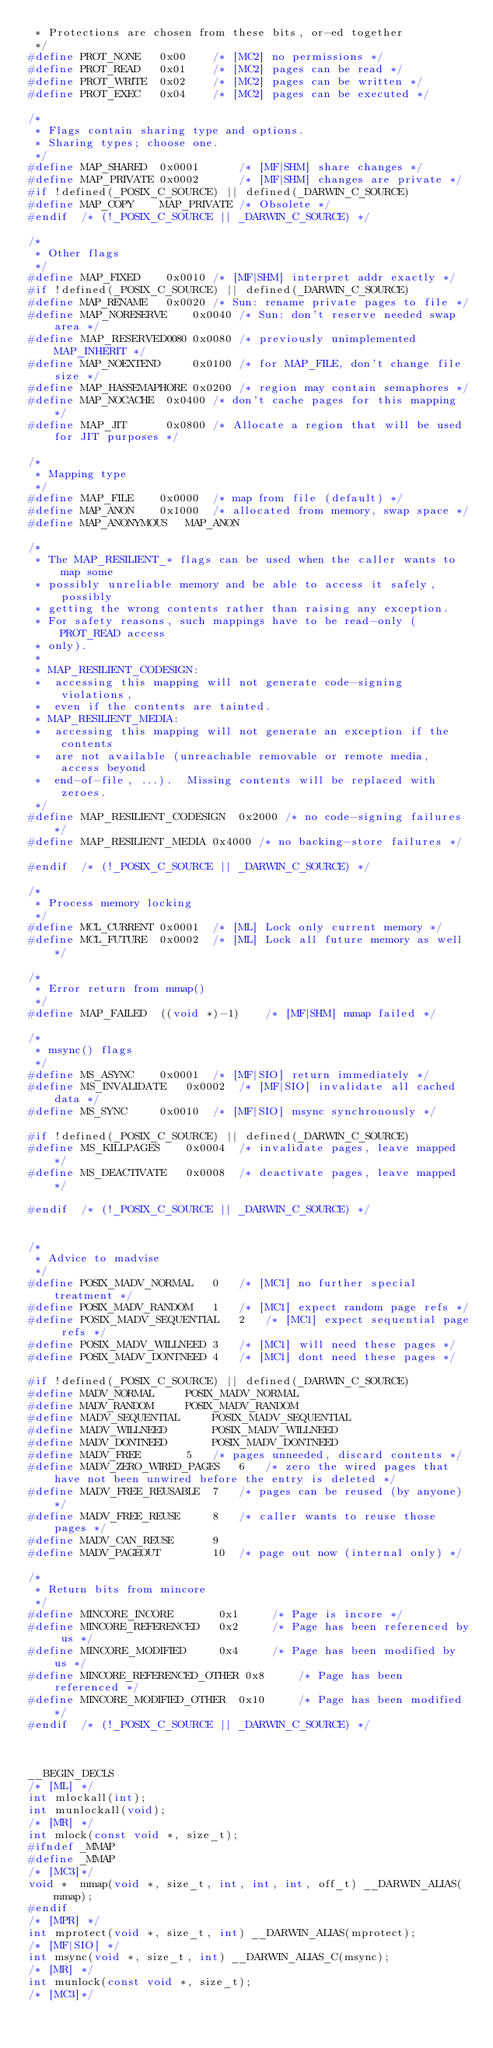Convert code to text. <code><loc_0><loc_0><loc_500><loc_500><_C_> * Protections are chosen from these bits, or-ed together
 */
#define	PROT_NONE	0x00	/* [MC2] no permissions */
#define	PROT_READ	0x01	/* [MC2] pages can be read */
#define	PROT_WRITE	0x02	/* [MC2] pages can be written */
#define	PROT_EXEC	0x04	/* [MC2] pages can be executed */

/*
 * Flags contain sharing type and options.
 * Sharing types; choose one.
 */
#define	MAP_SHARED	0x0001		/* [MF|SHM] share changes */
#define	MAP_PRIVATE	0x0002		/* [MF|SHM] changes are private */
#if !defined(_POSIX_C_SOURCE) || defined(_DARWIN_C_SOURCE)
#define	MAP_COPY	MAP_PRIVATE	/* Obsolete */
#endif	/* (!_POSIX_C_SOURCE || _DARWIN_C_SOURCE) */

/*
 * Other flags
 */
#define	MAP_FIXED	 0x0010	/* [MF|SHM] interpret addr exactly */
#if !defined(_POSIX_C_SOURCE) || defined(_DARWIN_C_SOURCE)
#define	MAP_RENAME	 0x0020	/* Sun: rename private pages to file */
#define	MAP_NORESERVE	 0x0040	/* Sun: don't reserve needed swap area */
#define	MAP_RESERVED0080 0x0080	/* previously unimplemented MAP_INHERIT */
#define	MAP_NOEXTEND	 0x0100	/* for MAP_FILE, don't change file size */
#define	MAP_HASSEMAPHORE 0x0200	/* region may contain semaphores */
#define MAP_NOCACHE	 0x0400 /* don't cache pages for this mapping */
#define MAP_JIT		 0x0800 /* Allocate a region that will be used for JIT purposes */

/*
 * Mapping type
 */
#define	MAP_FILE	0x0000	/* map from file (default) */
#define	MAP_ANON	0x1000	/* allocated from memory, swap space */
#define	MAP_ANONYMOUS	MAP_ANON

/*
 * The MAP_RESILIENT_* flags can be used when the caller wants to map some
 * possibly unreliable memory and be able to access it safely, possibly
 * getting the wrong contents rather than raising any exception.
 * For safety reasons, such mappings have to be read-only (PROT_READ access
 * only).
 *
 * MAP_RESILIENT_CODESIGN:
 * 	accessing this mapping will not generate code-signing violations,
 *	even if the contents are tainted.
 * MAP_RESILIENT_MEDIA:
 *	accessing this mapping will not generate an exception if the contents
 *	are not available (unreachable removable or remote media, access beyond
 *	end-of-file, ...).  Missing contents will be replaced with zeroes.
 */
#define MAP_RESILIENT_CODESIGN	0x2000 /* no code-signing failures */
#define MAP_RESILIENT_MEDIA	0x4000 /* no backing-store failures */

#endif	/* (!_POSIX_C_SOURCE || _DARWIN_C_SOURCE) */

/*
 * Process memory locking
 */
#define MCL_CURRENT	0x0001	/* [ML] Lock only current memory */
#define MCL_FUTURE	0x0002	/* [ML] Lock all future memory as well */

/*
 * Error return from mmap()
 */
#define MAP_FAILED	((void *)-1)	/* [MF|SHM] mmap failed */

/*
 * msync() flags
 */
#define MS_ASYNC	0x0001	/* [MF|SIO] return immediately */
#define MS_INVALIDATE	0x0002	/* [MF|SIO] invalidate all cached data */
#define	MS_SYNC		0x0010	/* [MF|SIO] msync synchronously */

#if !defined(_POSIX_C_SOURCE) || defined(_DARWIN_C_SOURCE)
#define MS_KILLPAGES    0x0004  /* invalidate pages, leave mapped */
#define MS_DEACTIVATE   0x0008  /* deactivate pages, leave mapped */

#endif	/* (!_POSIX_C_SOURCE || _DARWIN_C_SOURCE) */


/*
 * Advice to madvise
 */
#define	POSIX_MADV_NORMAL	0	/* [MC1] no further special treatment */
#define	POSIX_MADV_RANDOM	1	/* [MC1] expect random page refs */
#define	POSIX_MADV_SEQUENTIAL	2	/* [MC1] expect sequential page refs */
#define	POSIX_MADV_WILLNEED	3	/* [MC1] will need these pages */
#define	POSIX_MADV_DONTNEED	4	/* [MC1] dont need these pages */

#if !defined(_POSIX_C_SOURCE) || defined(_DARWIN_C_SOURCE)
#define	MADV_NORMAL		POSIX_MADV_NORMAL
#define	MADV_RANDOM		POSIX_MADV_RANDOM
#define	MADV_SEQUENTIAL		POSIX_MADV_SEQUENTIAL
#define	MADV_WILLNEED		POSIX_MADV_WILLNEED
#define	MADV_DONTNEED		POSIX_MADV_DONTNEED
#define	MADV_FREE		5	/* pages unneeded, discard contents */
#define	MADV_ZERO_WIRED_PAGES	6	/* zero the wired pages that have not been unwired before the entry is deleted */
#define MADV_FREE_REUSABLE	7	/* pages can be reused (by anyone) */
#define MADV_FREE_REUSE		8	/* caller wants to reuse those pages */
#define MADV_CAN_REUSE		9
#define MADV_PAGEOUT		10	/* page out now (internal only) */

/*
 * Return bits from mincore
 */
#define	MINCORE_INCORE	 	 0x1	 /* Page is incore */
#define	MINCORE_REFERENCED	 0x2	 /* Page has been referenced by us */
#define	MINCORE_MODIFIED	 0x4	 /* Page has been modified by us */
#define	MINCORE_REFERENCED_OTHER 0x8	 /* Page has been referenced */
#define	MINCORE_MODIFIED_OTHER	0x10	 /* Page has been modified */
#endif	/* (!_POSIX_C_SOURCE || _DARWIN_C_SOURCE) */



__BEGIN_DECLS
/* [ML] */
int	mlockall(int);
int	munlockall(void);
/* [MR] */
int	mlock(const void *, size_t);
#ifndef _MMAP
#define	_MMAP
/* [MC3]*/
void *	mmap(void *, size_t, int, int, int, off_t) __DARWIN_ALIAS(mmap);
#endif
/* [MPR] */
int	mprotect(void *, size_t, int) __DARWIN_ALIAS(mprotect);
/* [MF|SIO] */
int	msync(void *, size_t, int) __DARWIN_ALIAS_C(msync);
/* [MR] */
int	munlock(const void *, size_t);
/* [MC3]*/</code> 